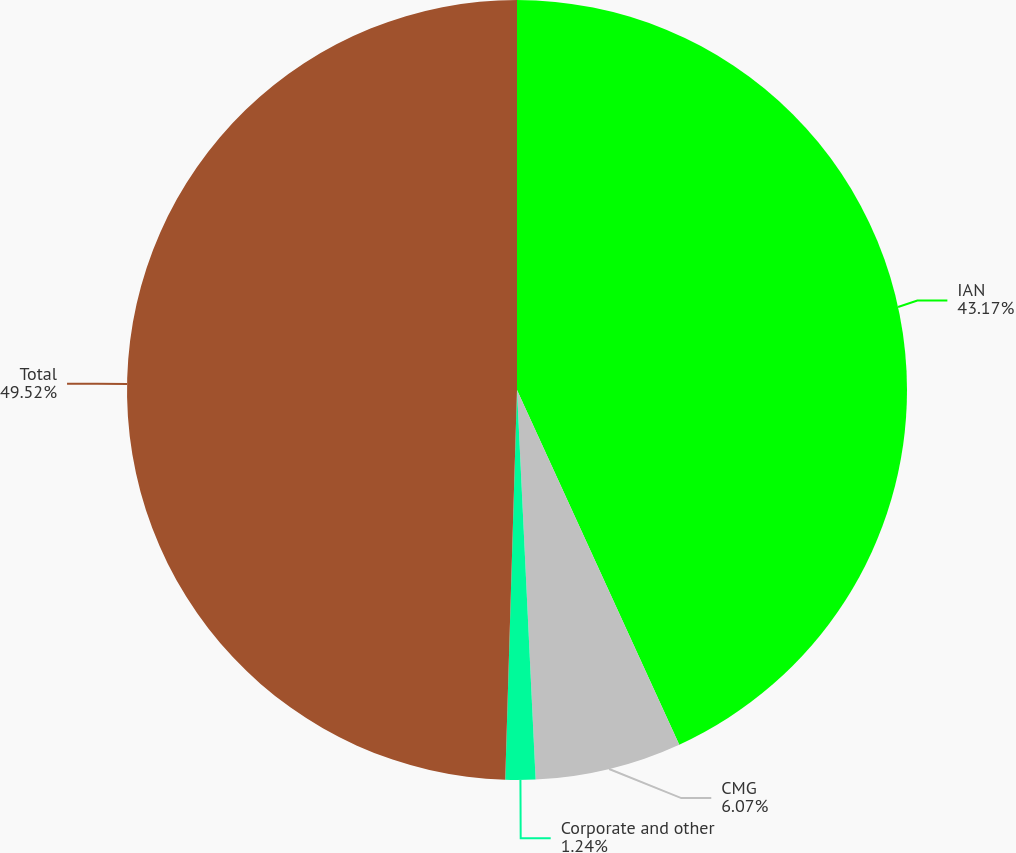Convert chart. <chart><loc_0><loc_0><loc_500><loc_500><pie_chart><fcel>IAN<fcel>CMG<fcel>Corporate and other<fcel>Total<nl><fcel>43.17%<fcel>6.07%<fcel>1.24%<fcel>49.52%<nl></chart> 